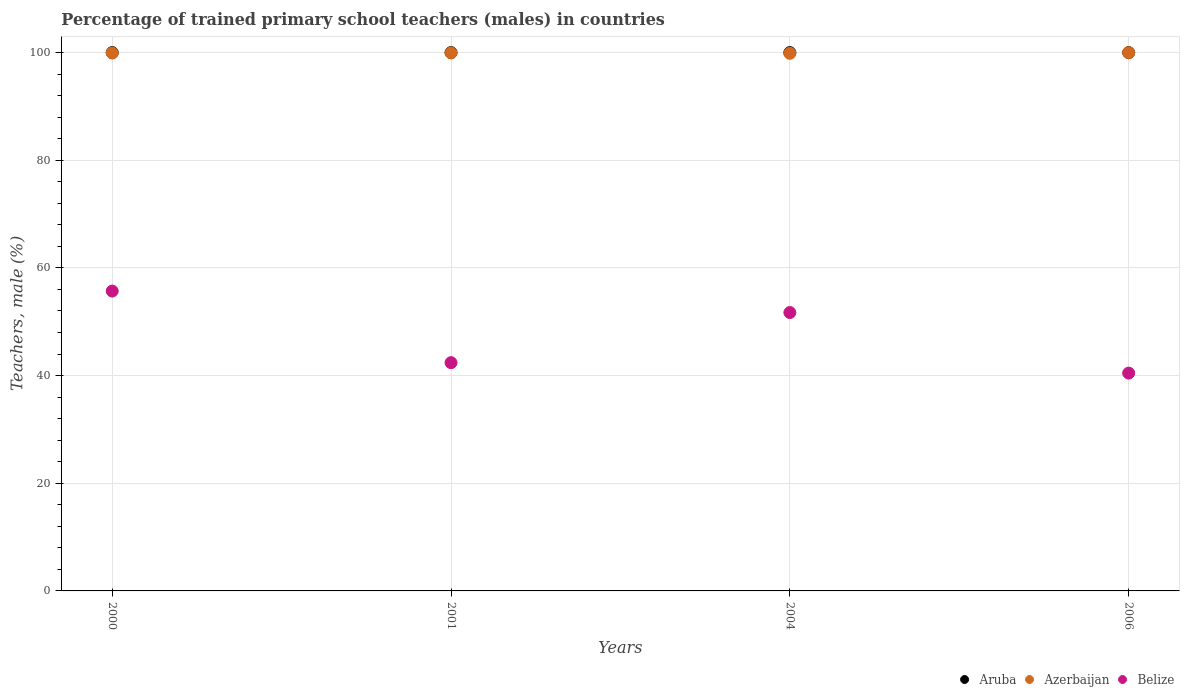What is the percentage of trained primary school teachers (males) in Belize in 2001?
Your response must be concise. 42.4. Across all years, what is the maximum percentage of trained primary school teachers (males) in Aruba?
Give a very brief answer. 100. Across all years, what is the minimum percentage of trained primary school teachers (males) in Azerbaijan?
Make the answer very short. 99.87. What is the total percentage of trained primary school teachers (males) in Aruba in the graph?
Your answer should be compact. 400. What is the difference between the percentage of trained primary school teachers (males) in Belize in 2000 and that in 2004?
Ensure brevity in your answer.  3.99. What is the difference between the percentage of trained primary school teachers (males) in Azerbaijan in 2006 and the percentage of trained primary school teachers (males) in Belize in 2001?
Make the answer very short. 57.58. In the year 2004, what is the difference between the percentage of trained primary school teachers (males) in Aruba and percentage of trained primary school teachers (males) in Azerbaijan?
Offer a very short reply. 0.13. Is the percentage of trained primary school teachers (males) in Belize in 2004 less than that in 2006?
Provide a short and direct response. No. What is the difference between the highest and the second highest percentage of trained primary school teachers (males) in Belize?
Make the answer very short. 3.99. What is the difference between the highest and the lowest percentage of trained primary school teachers (males) in Belize?
Ensure brevity in your answer.  15.24. In how many years, is the percentage of trained primary school teachers (males) in Aruba greater than the average percentage of trained primary school teachers (males) in Aruba taken over all years?
Offer a terse response. 0. Is the percentage of trained primary school teachers (males) in Belize strictly greater than the percentage of trained primary school teachers (males) in Azerbaijan over the years?
Ensure brevity in your answer.  No. Is the percentage of trained primary school teachers (males) in Belize strictly less than the percentage of trained primary school teachers (males) in Aruba over the years?
Make the answer very short. Yes. What is the difference between two consecutive major ticks on the Y-axis?
Provide a short and direct response. 20. Does the graph contain any zero values?
Ensure brevity in your answer.  No. Where does the legend appear in the graph?
Your answer should be very brief. Bottom right. How many legend labels are there?
Your answer should be compact. 3. What is the title of the graph?
Keep it short and to the point. Percentage of trained primary school teachers (males) in countries. What is the label or title of the Y-axis?
Ensure brevity in your answer.  Teachers, male (%). What is the Teachers, male (%) of Aruba in 2000?
Make the answer very short. 100. What is the Teachers, male (%) in Azerbaijan in 2000?
Ensure brevity in your answer.  99.92. What is the Teachers, male (%) of Belize in 2000?
Offer a very short reply. 55.7. What is the Teachers, male (%) of Azerbaijan in 2001?
Offer a very short reply. 99.94. What is the Teachers, male (%) of Belize in 2001?
Provide a short and direct response. 42.4. What is the Teachers, male (%) in Aruba in 2004?
Give a very brief answer. 100. What is the Teachers, male (%) of Azerbaijan in 2004?
Provide a succinct answer. 99.87. What is the Teachers, male (%) of Belize in 2004?
Provide a short and direct response. 51.71. What is the Teachers, male (%) of Azerbaijan in 2006?
Provide a short and direct response. 99.98. What is the Teachers, male (%) of Belize in 2006?
Provide a succinct answer. 40.46. Across all years, what is the maximum Teachers, male (%) in Azerbaijan?
Your response must be concise. 99.98. Across all years, what is the maximum Teachers, male (%) in Belize?
Provide a succinct answer. 55.7. Across all years, what is the minimum Teachers, male (%) of Azerbaijan?
Give a very brief answer. 99.87. Across all years, what is the minimum Teachers, male (%) in Belize?
Your response must be concise. 40.46. What is the total Teachers, male (%) of Azerbaijan in the graph?
Make the answer very short. 399.71. What is the total Teachers, male (%) of Belize in the graph?
Your answer should be compact. 190.28. What is the difference between the Teachers, male (%) in Aruba in 2000 and that in 2001?
Offer a terse response. 0. What is the difference between the Teachers, male (%) of Azerbaijan in 2000 and that in 2001?
Give a very brief answer. -0.02. What is the difference between the Teachers, male (%) in Belize in 2000 and that in 2001?
Provide a short and direct response. 13.3. What is the difference between the Teachers, male (%) in Aruba in 2000 and that in 2004?
Make the answer very short. 0. What is the difference between the Teachers, male (%) in Azerbaijan in 2000 and that in 2004?
Make the answer very short. 0.05. What is the difference between the Teachers, male (%) of Belize in 2000 and that in 2004?
Offer a very short reply. 3.99. What is the difference between the Teachers, male (%) in Aruba in 2000 and that in 2006?
Your answer should be compact. 0. What is the difference between the Teachers, male (%) in Azerbaijan in 2000 and that in 2006?
Your response must be concise. -0.06. What is the difference between the Teachers, male (%) in Belize in 2000 and that in 2006?
Provide a succinct answer. 15.24. What is the difference between the Teachers, male (%) in Azerbaijan in 2001 and that in 2004?
Provide a short and direct response. 0.07. What is the difference between the Teachers, male (%) in Belize in 2001 and that in 2004?
Keep it short and to the point. -9.31. What is the difference between the Teachers, male (%) in Azerbaijan in 2001 and that in 2006?
Keep it short and to the point. -0.03. What is the difference between the Teachers, male (%) of Belize in 2001 and that in 2006?
Your response must be concise. 1.94. What is the difference between the Teachers, male (%) of Aruba in 2004 and that in 2006?
Provide a short and direct response. 0. What is the difference between the Teachers, male (%) of Azerbaijan in 2004 and that in 2006?
Ensure brevity in your answer.  -0.11. What is the difference between the Teachers, male (%) of Belize in 2004 and that in 2006?
Give a very brief answer. 11.25. What is the difference between the Teachers, male (%) of Aruba in 2000 and the Teachers, male (%) of Azerbaijan in 2001?
Your answer should be very brief. 0.06. What is the difference between the Teachers, male (%) in Aruba in 2000 and the Teachers, male (%) in Belize in 2001?
Give a very brief answer. 57.6. What is the difference between the Teachers, male (%) of Azerbaijan in 2000 and the Teachers, male (%) of Belize in 2001?
Offer a terse response. 57.52. What is the difference between the Teachers, male (%) in Aruba in 2000 and the Teachers, male (%) in Azerbaijan in 2004?
Give a very brief answer. 0.13. What is the difference between the Teachers, male (%) in Aruba in 2000 and the Teachers, male (%) in Belize in 2004?
Offer a very short reply. 48.29. What is the difference between the Teachers, male (%) of Azerbaijan in 2000 and the Teachers, male (%) of Belize in 2004?
Provide a short and direct response. 48.21. What is the difference between the Teachers, male (%) in Aruba in 2000 and the Teachers, male (%) in Azerbaijan in 2006?
Keep it short and to the point. 0.02. What is the difference between the Teachers, male (%) of Aruba in 2000 and the Teachers, male (%) of Belize in 2006?
Offer a terse response. 59.54. What is the difference between the Teachers, male (%) in Azerbaijan in 2000 and the Teachers, male (%) in Belize in 2006?
Give a very brief answer. 59.46. What is the difference between the Teachers, male (%) in Aruba in 2001 and the Teachers, male (%) in Azerbaijan in 2004?
Your answer should be compact. 0.13. What is the difference between the Teachers, male (%) in Aruba in 2001 and the Teachers, male (%) in Belize in 2004?
Your answer should be compact. 48.29. What is the difference between the Teachers, male (%) in Azerbaijan in 2001 and the Teachers, male (%) in Belize in 2004?
Make the answer very short. 48.23. What is the difference between the Teachers, male (%) in Aruba in 2001 and the Teachers, male (%) in Azerbaijan in 2006?
Provide a succinct answer. 0.02. What is the difference between the Teachers, male (%) of Aruba in 2001 and the Teachers, male (%) of Belize in 2006?
Make the answer very short. 59.54. What is the difference between the Teachers, male (%) in Azerbaijan in 2001 and the Teachers, male (%) in Belize in 2006?
Ensure brevity in your answer.  59.48. What is the difference between the Teachers, male (%) of Aruba in 2004 and the Teachers, male (%) of Azerbaijan in 2006?
Offer a very short reply. 0.02. What is the difference between the Teachers, male (%) of Aruba in 2004 and the Teachers, male (%) of Belize in 2006?
Your answer should be compact. 59.54. What is the difference between the Teachers, male (%) of Azerbaijan in 2004 and the Teachers, male (%) of Belize in 2006?
Offer a terse response. 59.41. What is the average Teachers, male (%) of Azerbaijan per year?
Your response must be concise. 99.93. What is the average Teachers, male (%) in Belize per year?
Give a very brief answer. 47.57. In the year 2000, what is the difference between the Teachers, male (%) of Aruba and Teachers, male (%) of Azerbaijan?
Your response must be concise. 0.08. In the year 2000, what is the difference between the Teachers, male (%) of Aruba and Teachers, male (%) of Belize?
Give a very brief answer. 44.3. In the year 2000, what is the difference between the Teachers, male (%) in Azerbaijan and Teachers, male (%) in Belize?
Make the answer very short. 44.22. In the year 2001, what is the difference between the Teachers, male (%) in Aruba and Teachers, male (%) in Azerbaijan?
Give a very brief answer. 0.06. In the year 2001, what is the difference between the Teachers, male (%) in Aruba and Teachers, male (%) in Belize?
Ensure brevity in your answer.  57.6. In the year 2001, what is the difference between the Teachers, male (%) of Azerbaijan and Teachers, male (%) of Belize?
Offer a terse response. 57.54. In the year 2004, what is the difference between the Teachers, male (%) in Aruba and Teachers, male (%) in Azerbaijan?
Provide a short and direct response. 0.13. In the year 2004, what is the difference between the Teachers, male (%) in Aruba and Teachers, male (%) in Belize?
Keep it short and to the point. 48.29. In the year 2004, what is the difference between the Teachers, male (%) of Azerbaijan and Teachers, male (%) of Belize?
Your response must be concise. 48.16. In the year 2006, what is the difference between the Teachers, male (%) in Aruba and Teachers, male (%) in Azerbaijan?
Ensure brevity in your answer.  0.02. In the year 2006, what is the difference between the Teachers, male (%) in Aruba and Teachers, male (%) in Belize?
Your answer should be very brief. 59.54. In the year 2006, what is the difference between the Teachers, male (%) in Azerbaijan and Teachers, male (%) in Belize?
Ensure brevity in your answer.  59.52. What is the ratio of the Teachers, male (%) of Aruba in 2000 to that in 2001?
Your response must be concise. 1. What is the ratio of the Teachers, male (%) of Azerbaijan in 2000 to that in 2001?
Offer a very short reply. 1. What is the ratio of the Teachers, male (%) in Belize in 2000 to that in 2001?
Your answer should be compact. 1.31. What is the ratio of the Teachers, male (%) of Aruba in 2000 to that in 2004?
Your response must be concise. 1. What is the ratio of the Teachers, male (%) in Belize in 2000 to that in 2004?
Provide a succinct answer. 1.08. What is the ratio of the Teachers, male (%) in Belize in 2000 to that in 2006?
Ensure brevity in your answer.  1.38. What is the ratio of the Teachers, male (%) in Azerbaijan in 2001 to that in 2004?
Offer a very short reply. 1. What is the ratio of the Teachers, male (%) in Belize in 2001 to that in 2004?
Offer a very short reply. 0.82. What is the ratio of the Teachers, male (%) of Belize in 2001 to that in 2006?
Give a very brief answer. 1.05. What is the ratio of the Teachers, male (%) of Azerbaijan in 2004 to that in 2006?
Make the answer very short. 1. What is the ratio of the Teachers, male (%) of Belize in 2004 to that in 2006?
Offer a terse response. 1.28. What is the difference between the highest and the second highest Teachers, male (%) of Azerbaijan?
Ensure brevity in your answer.  0.03. What is the difference between the highest and the second highest Teachers, male (%) in Belize?
Provide a succinct answer. 3.99. What is the difference between the highest and the lowest Teachers, male (%) in Aruba?
Offer a terse response. 0. What is the difference between the highest and the lowest Teachers, male (%) of Azerbaijan?
Ensure brevity in your answer.  0.11. What is the difference between the highest and the lowest Teachers, male (%) of Belize?
Provide a short and direct response. 15.24. 